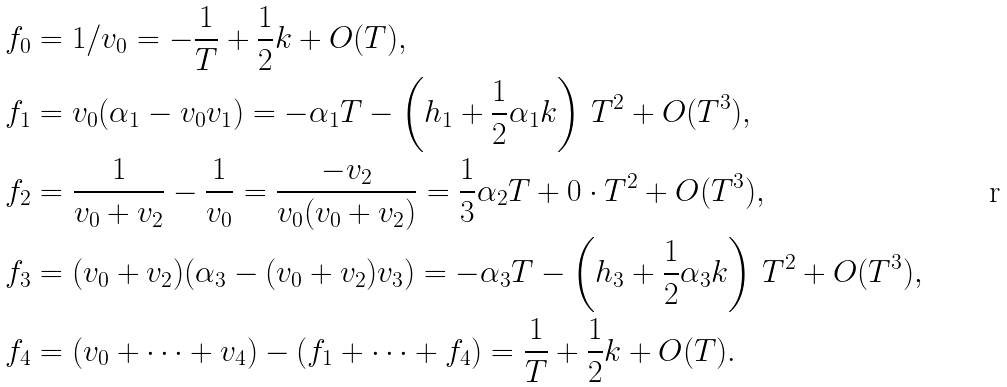<formula> <loc_0><loc_0><loc_500><loc_500>f _ { 0 } & = 1 / v _ { 0 } = - \frac { 1 } { T } + \frac { 1 } { 2 } k + O ( T ) , \\ f _ { 1 } & = v _ { 0 } ( \alpha _ { 1 } - v _ { 0 } v _ { 1 } ) = - \alpha _ { 1 } T - \left ( h _ { 1 } + \frac { 1 } { 2 } \alpha _ { 1 } k \right ) \, T ^ { 2 } + O ( T ^ { 3 } ) , \\ f _ { 2 } & = \frac { 1 } { v _ { 0 } + v _ { 2 } } - \frac { 1 } { v _ { 0 } } = \frac { - v _ { 2 } } { v _ { 0 } ( v _ { 0 } + v _ { 2 } ) } = \frac { 1 } { 3 } \alpha _ { 2 } T + 0 \cdot T ^ { 2 } + O ( T ^ { 3 } ) , \\ f _ { 3 } & = ( v _ { 0 } + v _ { 2 } ) ( \alpha _ { 3 } - ( v _ { 0 } + v _ { 2 } ) v _ { 3 } ) = - \alpha _ { 3 } T - \left ( h _ { 3 } + \frac { 1 } { 2 } \alpha _ { 3 } k \right ) \, T ^ { 2 } + O ( T ^ { 3 } ) , \\ f _ { 4 } & = ( v _ { 0 } + \cdots + v _ { 4 } ) - ( f _ { 1 } + \cdots + f _ { 4 } ) = \frac { 1 } { T } + \frac { 1 } { 2 } k + O ( T ) .</formula> 